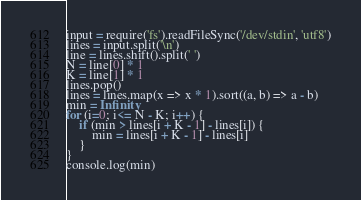Convert code to text. <code><loc_0><loc_0><loc_500><loc_500><_JavaScript_>input = require('fs').readFileSync('/dev/stdin', 'utf8')
lines = input.split('\n')
line = lines.shift().split(' ')
N = line[0] * 1
K = line[1] * 1 
lines.pop()
lines = lines.map(x => x * 1).sort((a, b) => a - b)
min = Infinity
for (i=0; i<= N - K; i++) {
    if (min > lines[i + K - 1] - lines[i]) {
        min = lines[i + K - 1] - lines[i]
    }
}
console.log(min)</code> 